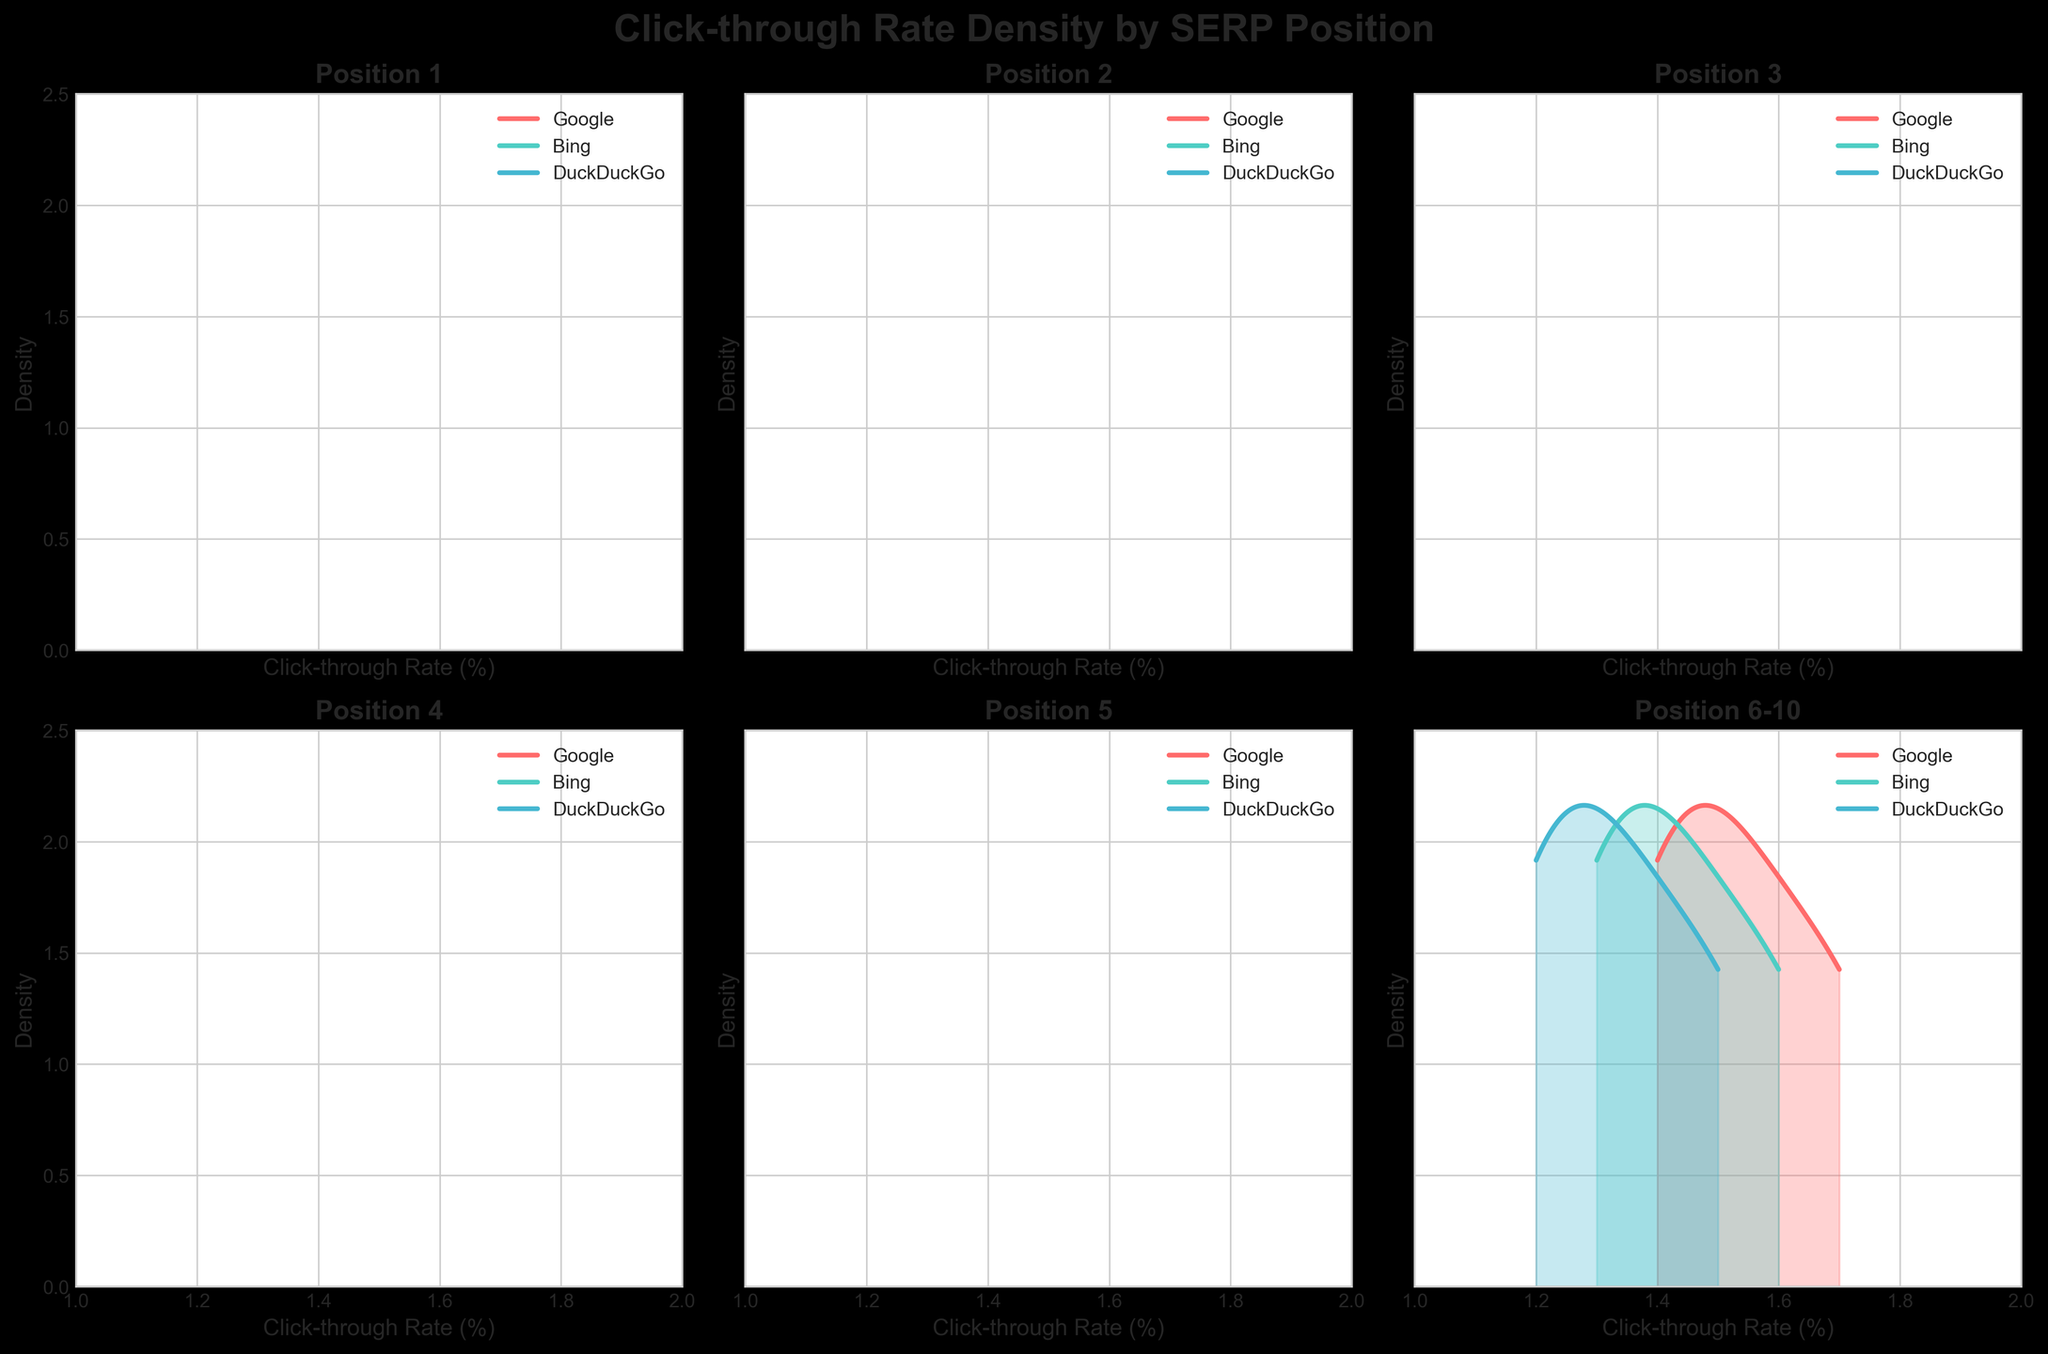What is the title of the figure? The title of the figure is usually placed at the top of the plot. Here, it reads "Click-through Rate Density by SERP Position."
Answer: Click-through Rate Density by SERP Position Which search engine has the highest density at position 1? At position 1, the density plot with the highest peak shows the greatest density. For position 1, Google's CTR density is the highest compared to Bing and DuckDuckGo.
Answer: Google What is the range of Click-through Rates (CTR) for position 5? The x-axis range for position 5 is limited to 2.3% to 3.5% as indicated by the x-axis ticks.
Answer: 2.3%-3.5% How do the CTR density peaks for position 2 compare between Google and DuckDuckGo? To determine the relative peak heights, look at the y-values at the peaks of the density curves. For position 2, Google's peak is higher than DuckDuckGo's.
Answer: Google's peak is higher For which position is the difference between the x-axis limits the largest? By comparing the x-axis limits for each subplot, position 1 has the largest difference (21-14 = 7).
Answer: Position 1 What is the general trend of CTR as the position number increases? By observing the x-axis ranges and density curves for each position from 1 to 6-10, it's clear that CTR decreases as the position number increases.
Answer: CTR decreases Compare the density shapes for Bing and DuckDuckGo at position 3. Both density plots have similar shapes, but Bing's density curve is slightly higher and shifts to the right compared to DuckDuckGo's curve.
Answer: Bing's curve is slightly higher and shifted to the right Which search engine shows the least variation in CTR at position 4? By examining the width of the density curves, the search engine with the narrowest curve shows the least variation. At position 4, Bing's density curve is the narrowest.
Answer: Bing How do the densities for position 6-10 differ between the three search engines? The densities for Google, Bing, and DuckDuckGo at position 6-10 are relatively similar, but Google's density curve is slightly higher than the others.
Answer: Google's density curve is slightly higher Which position exhibits the most overlap in CTR densities between the three search engines? Overlap can be assessed by looking at the intersection regions of the density curves. Position 5 exhibits significant overlap among the density curves of Google, Bing, and DuckDuckGo.
Answer: Position 5 